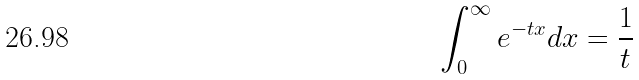Convert formula to latex. <formula><loc_0><loc_0><loc_500><loc_500>\int _ { 0 } ^ { \infty } e ^ { - t x } d x = \frac { 1 } { t }</formula> 